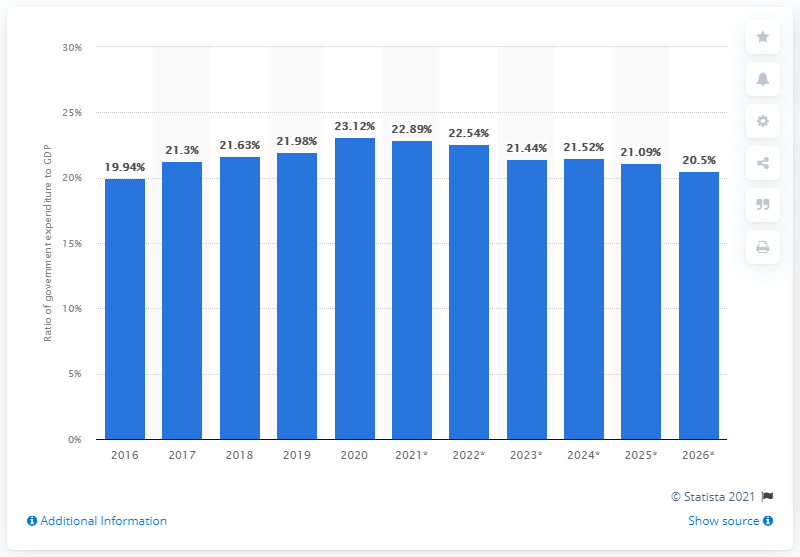Mention a couple of crucial points in this snapshot. In 2020, government expenditure in Pakistan accounted for 22.89% of the country's Gross Domestic Product (GDP). 